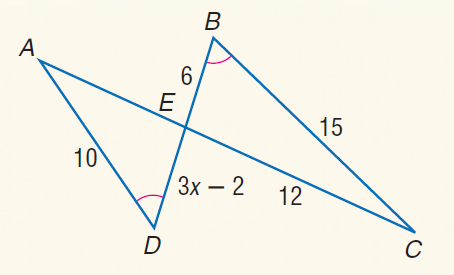Question: Find A E.
Choices:
A. 6
B. 7
C. 8
D. 9
Answer with the letter. Answer: C Question: Find x.
Choices:
A. 1.5
B. 2
C. 3
D. 4
Answer with the letter. Answer: B 